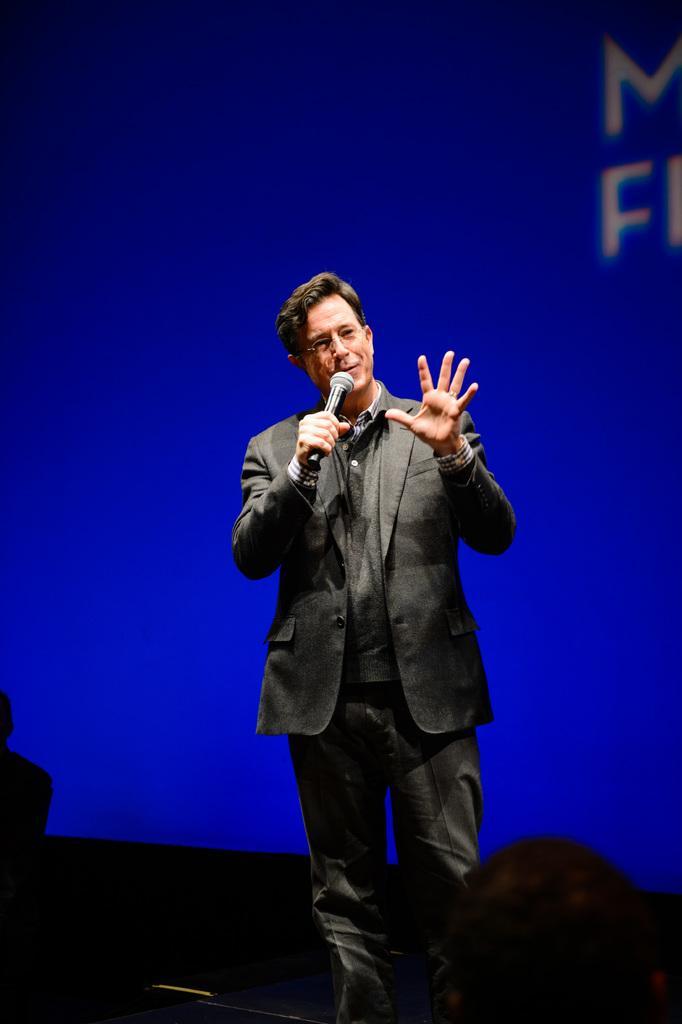Can you describe this image briefly? Here we can see a man holding a mike with his hand. In the background there is a banner. 